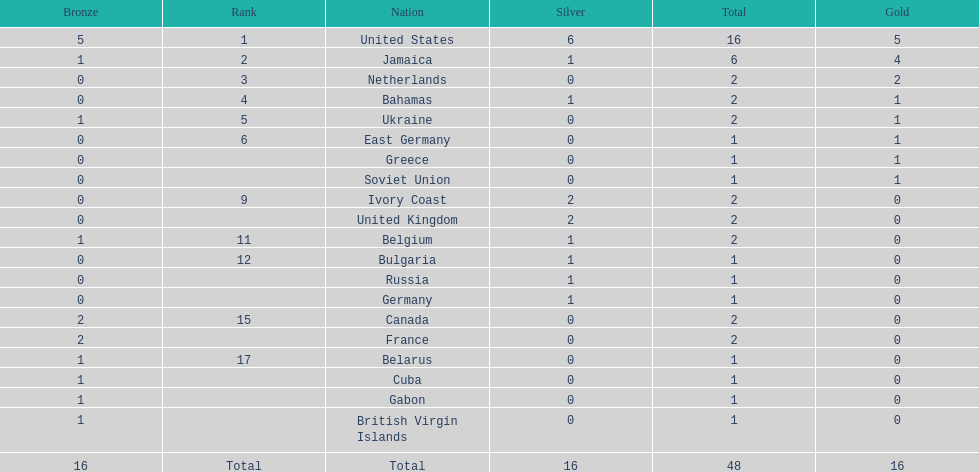Among the top 5 countries, what is the typical quantity of gold medals earned? 2.6. 